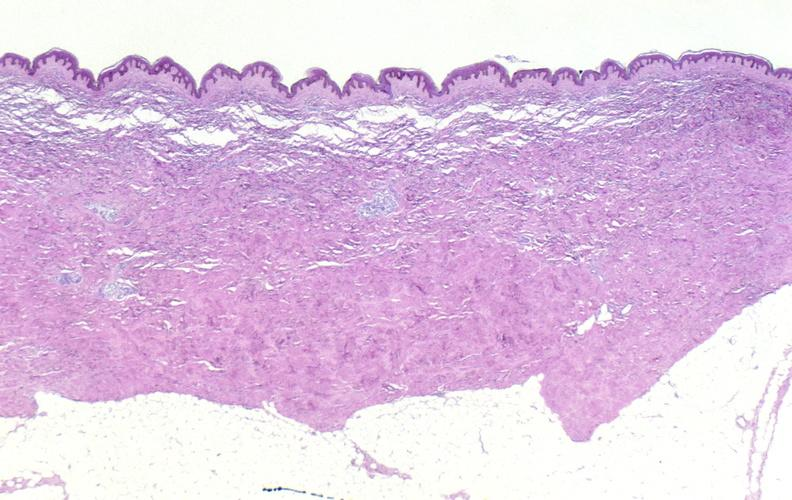where is this?
Answer the question using a single word or phrase. Skin 